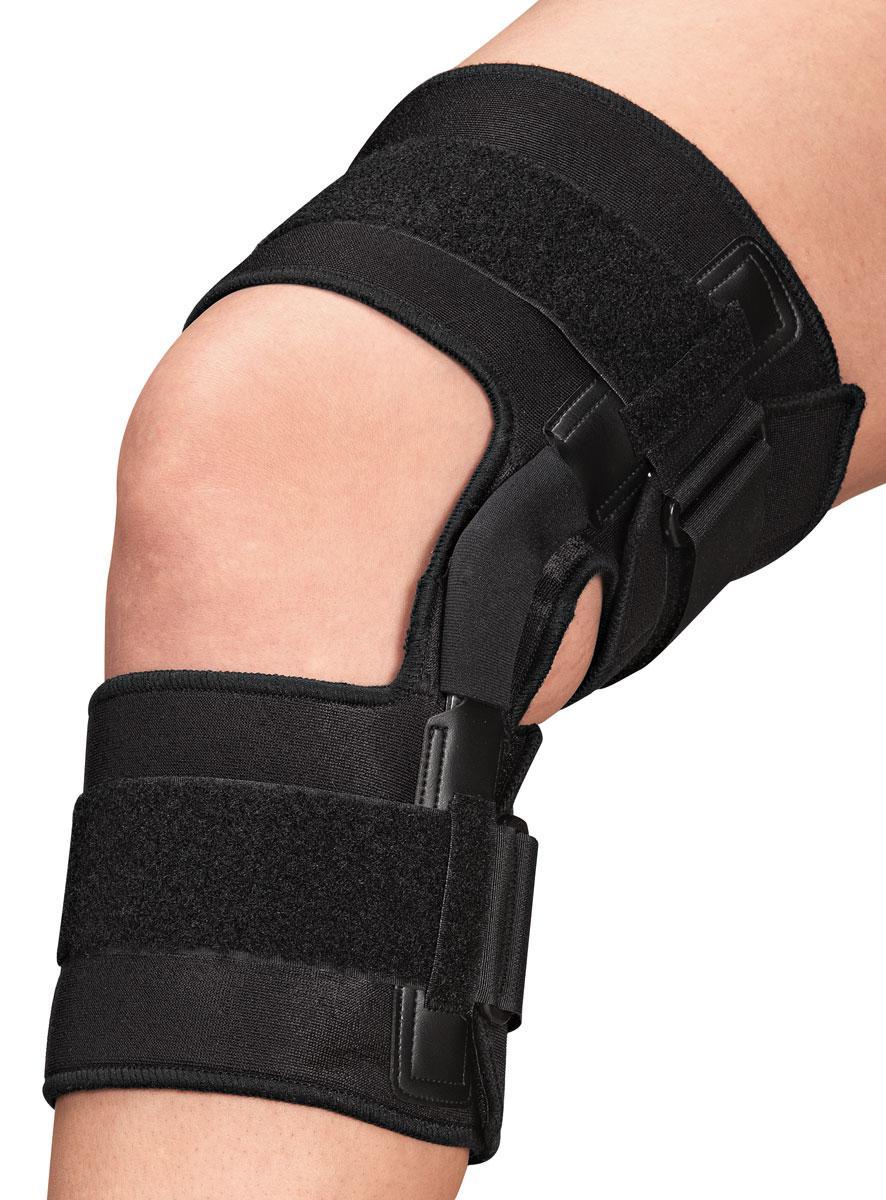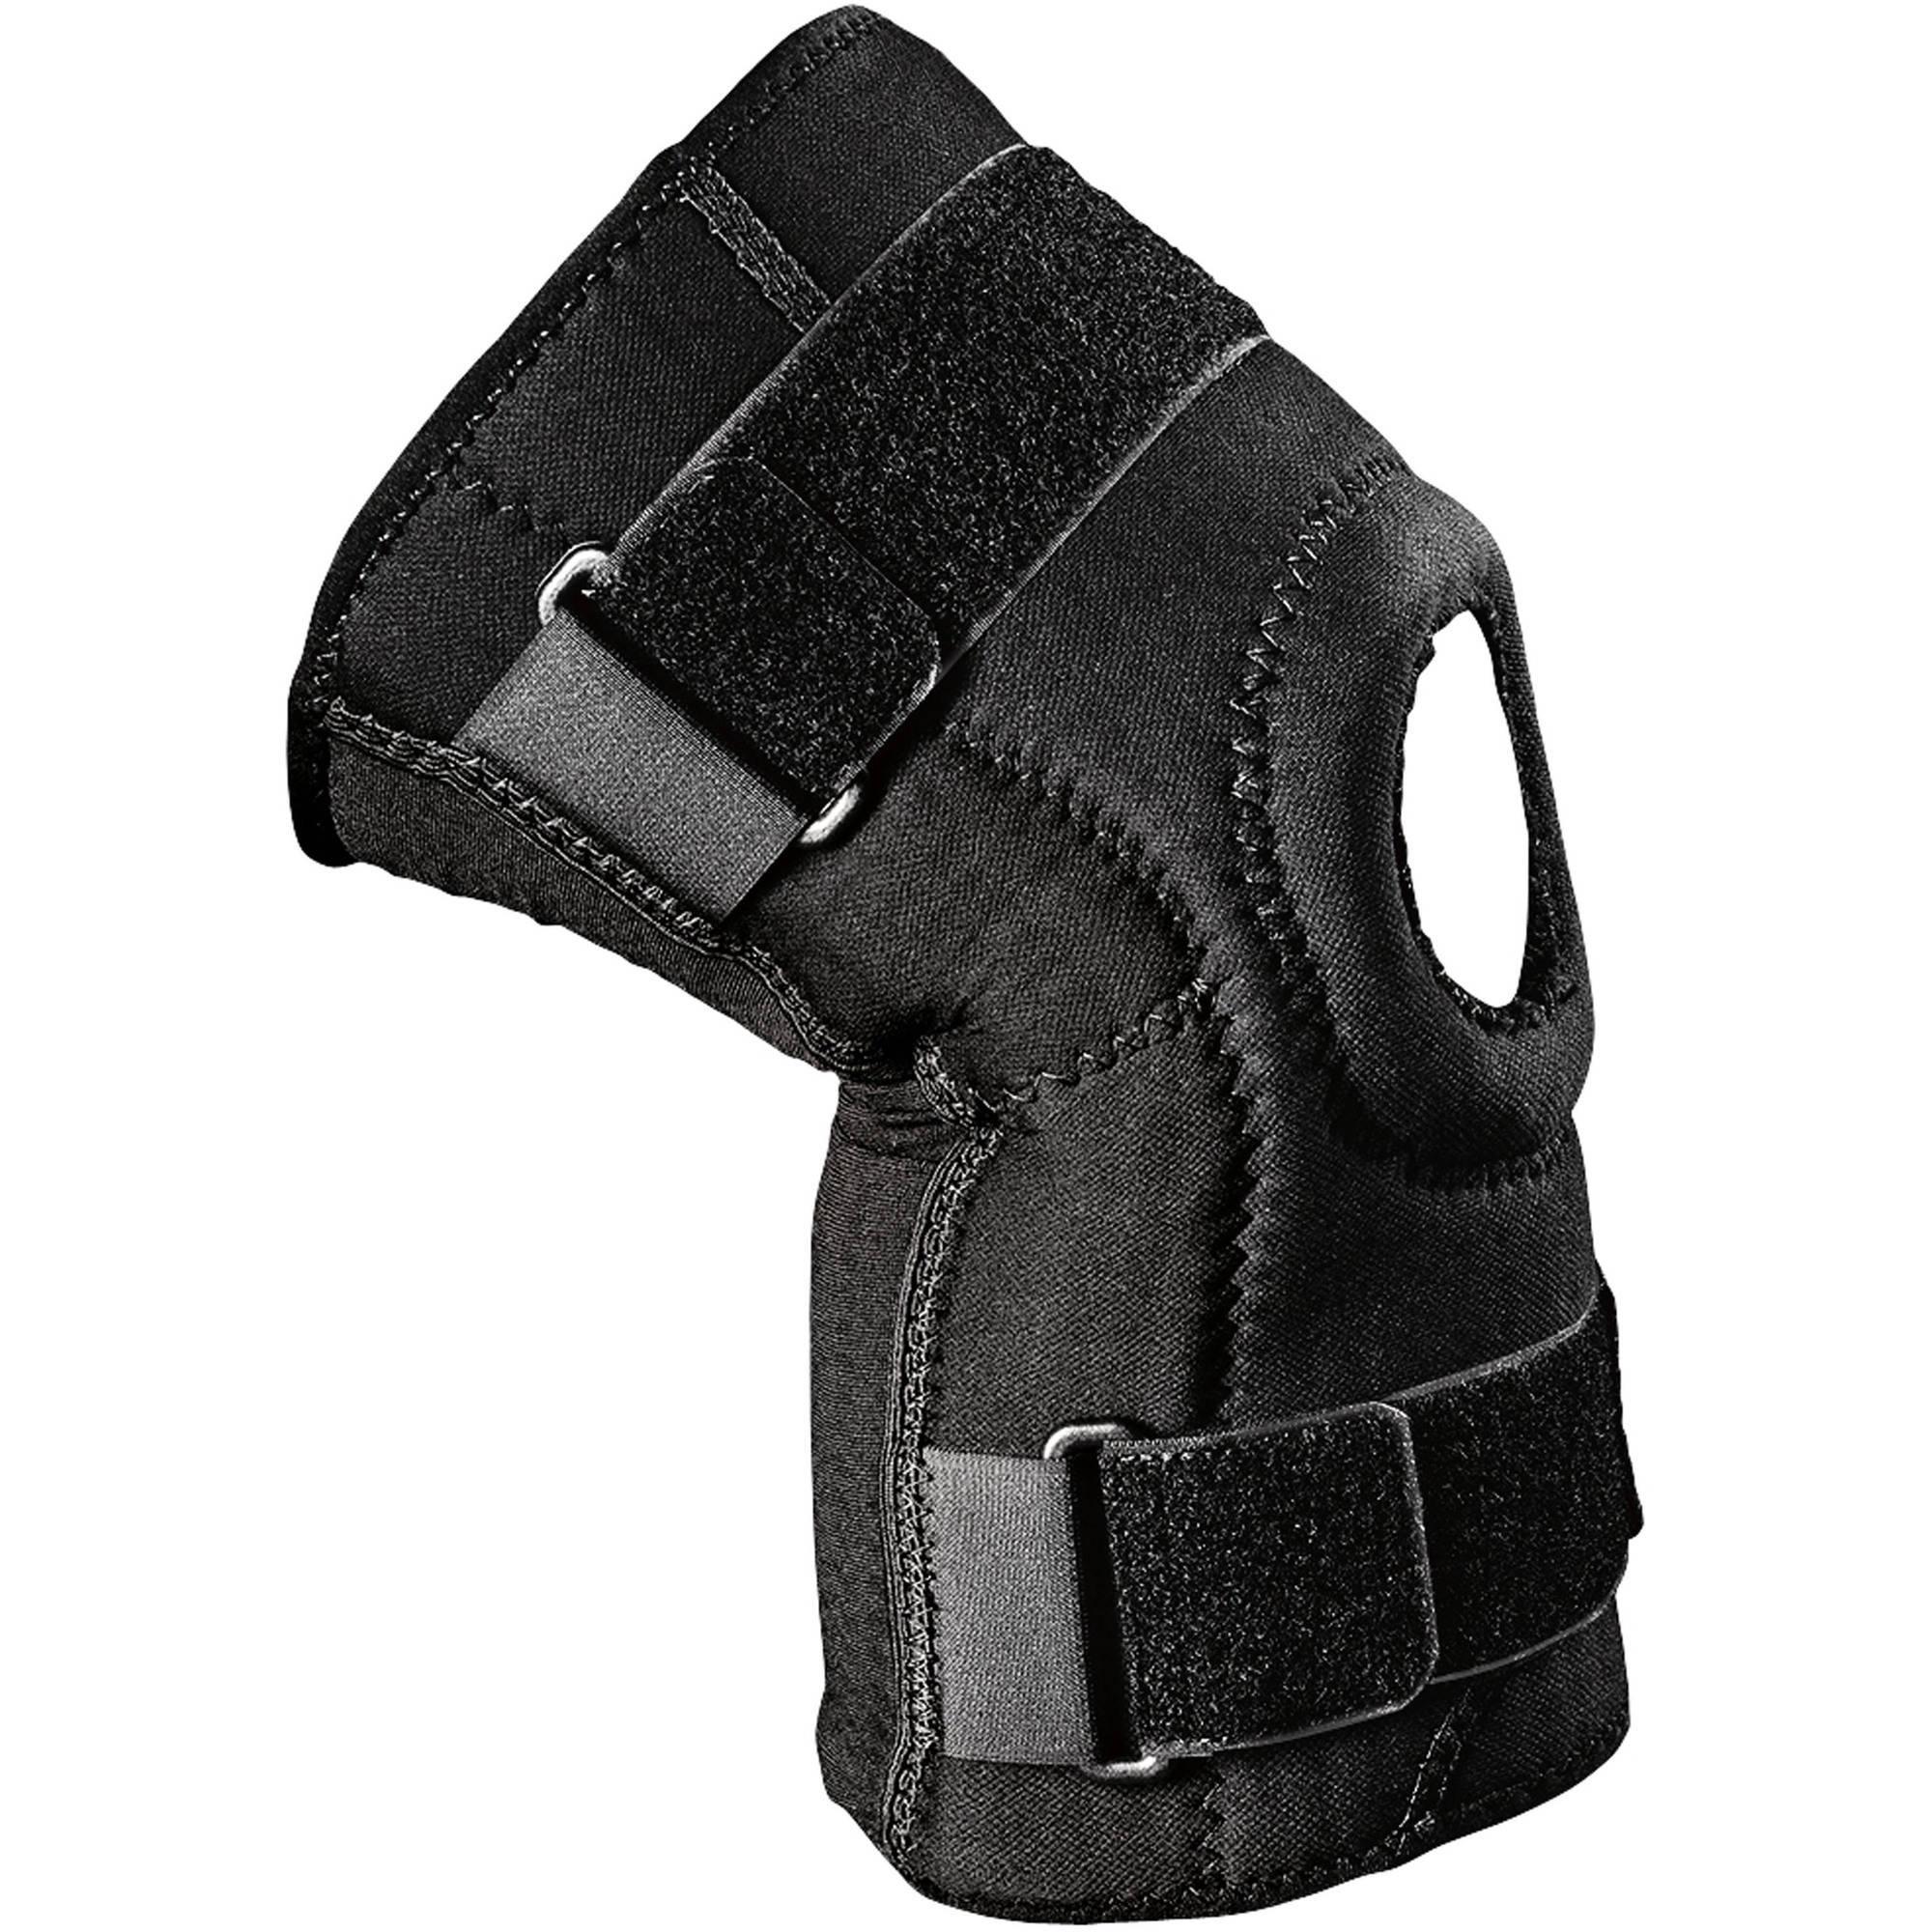The first image is the image on the left, the second image is the image on the right. Assess this claim about the two images: "One image shows the knee brace package.". Correct or not? Answer yes or no. No. The first image is the image on the left, the second image is the image on the right. Considering the images on both sides, is "One of the images shows exactly two knee braces." valid? Answer yes or no. No. The first image is the image on the left, the second image is the image on the right. Evaluate the accuracy of this statement regarding the images: "One of the images features a knee pad still in its red packaging". Is it true? Answer yes or no. No. 